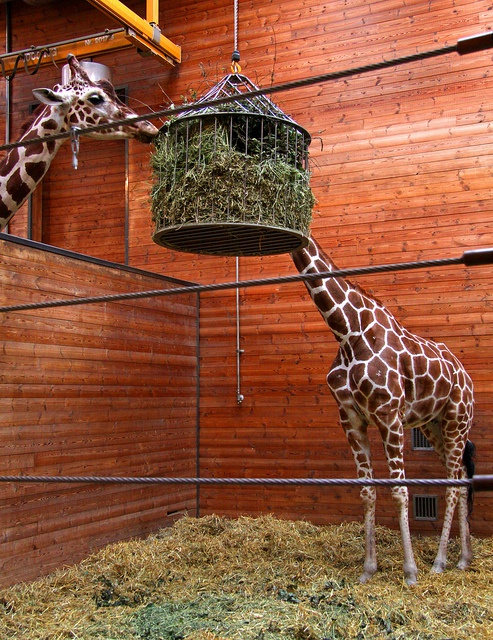Describe the objects in this image and their specific colors. I can see giraffe in maroon, brown, black, and darkgray tones and giraffe in maroon, black, and gray tones in this image. 